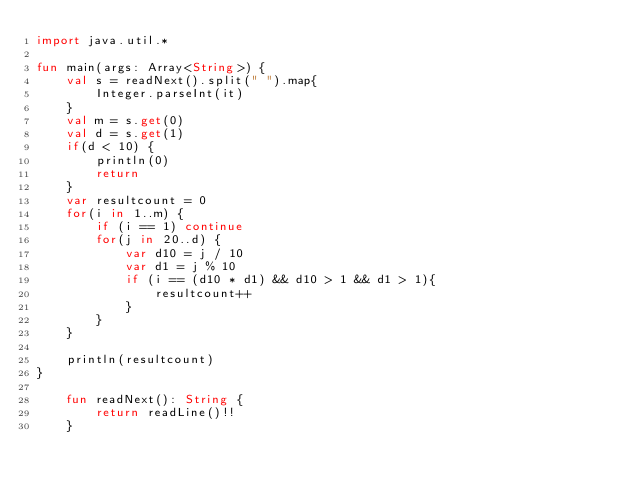<code> <loc_0><loc_0><loc_500><loc_500><_Kotlin_>import java.util.*

fun main(args: Array<String>) {
    val s = readNext().split(" ").map{
        Integer.parseInt(it)
    }
    val m = s.get(0)
    val d = s.get(1)
    if(d < 10) {
        println(0)
        return
    }
    var resultcount = 0
    for(i in 1..m) {
        if (i == 1) continue
        for(j in 20..d) {
            var d10 = j / 10
            var d1 = j % 10
            if (i == (d10 * d1) && d10 > 1 && d1 > 1){
                resultcount++
            }
        }
    }

    println(resultcount)
}

    fun readNext(): String {
        return readLine()!!
    }</code> 